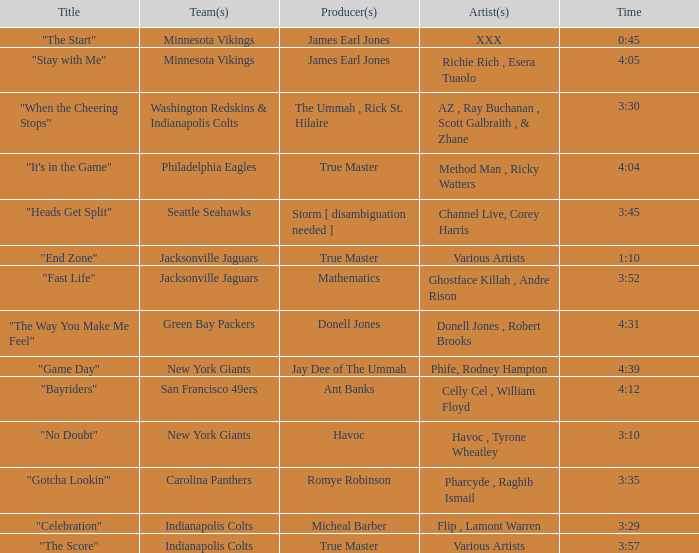How long is the XXX track used by the Minnesota Vikings? 0:45. 